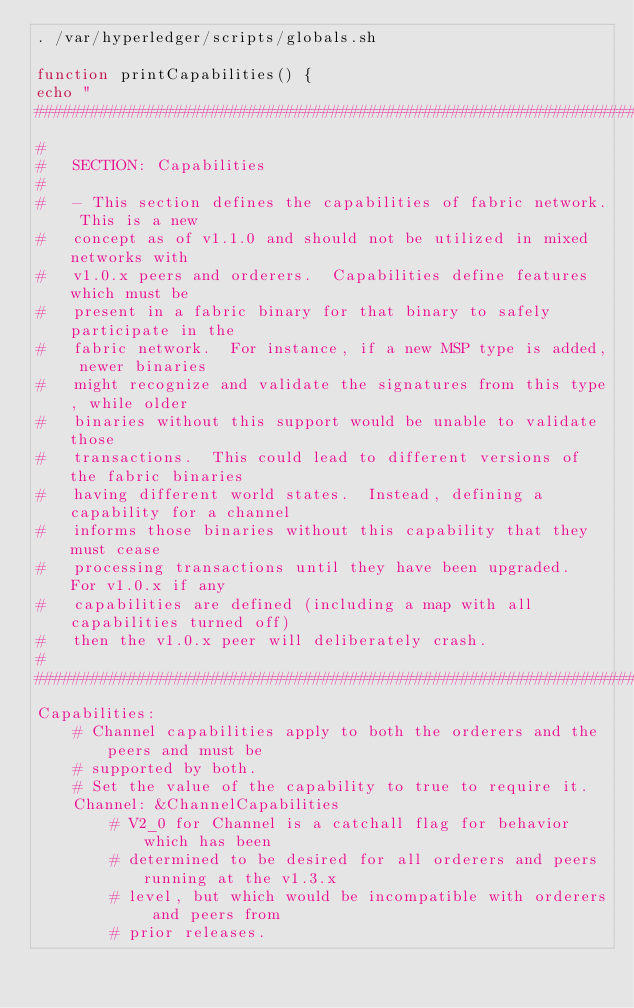<code> <loc_0><loc_0><loc_500><loc_500><_Bash_>. /var/hyperledger/scripts/globals.sh

function printCapabilities() {
echo "
################################################################################
#
#   SECTION: Capabilities
#
#   - This section defines the capabilities of fabric network. This is a new
#   concept as of v1.1.0 and should not be utilized in mixed networks with
#   v1.0.x peers and orderers.  Capabilities define features which must be
#   present in a fabric binary for that binary to safely participate in the
#   fabric network.  For instance, if a new MSP type is added, newer binaries
#   might recognize and validate the signatures from this type, while older
#   binaries without this support would be unable to validate those
#   transactions.  This could lead to different versions of the fabric binaries
#   having different world states.  Instead, defining a capability for a channel
#   informs those binaries without this capability that they must cease
#   processing transactions until they have been upgraded.  For v1.0.x if any
#   capabilities are defined (including a map with all capabilities turned off)
#   then the v1.0.x peer will deliberately crash.
#
################################################################################
Capabilities:
    # Channel capabilities apply to both the orderers and the peers and must be
    # supported by both.
    # Set the value of the capability to true to require it.
    Channel: &ChannelCapabilities
        # V2_0 for Channel is a catchall flag for behavior which has been
        # determined to be desired for all orderers and peers running at the v1.3.x
        # level, but which would be incompatible with orderers and peers from
        # prior releases.</code> 